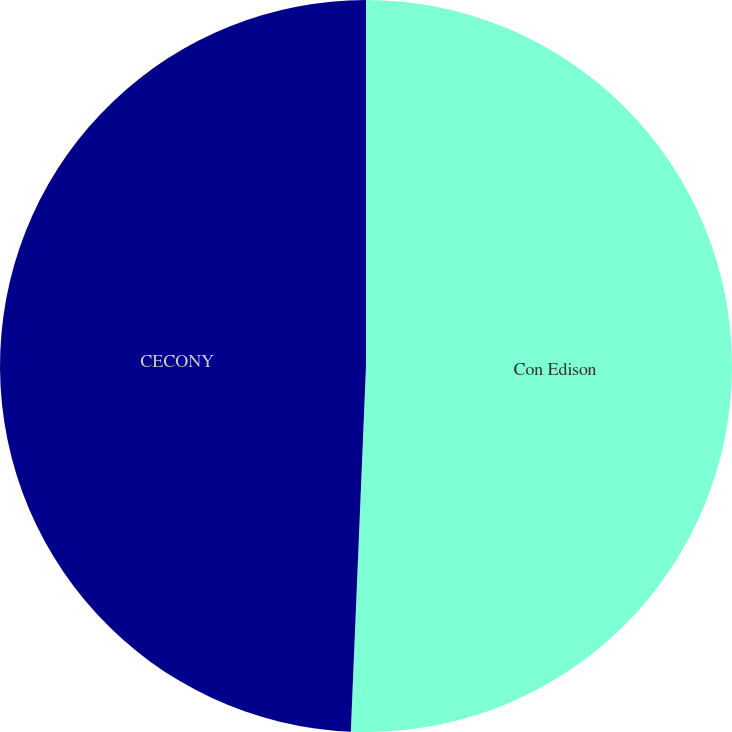<chart> <loc_0><loc_0><loc_500><loc_500><pie_chart><fcel>Con Edison<fcel>CECONY<nl><fcel>50.66%<fcel>49.34%<nl></chart> 